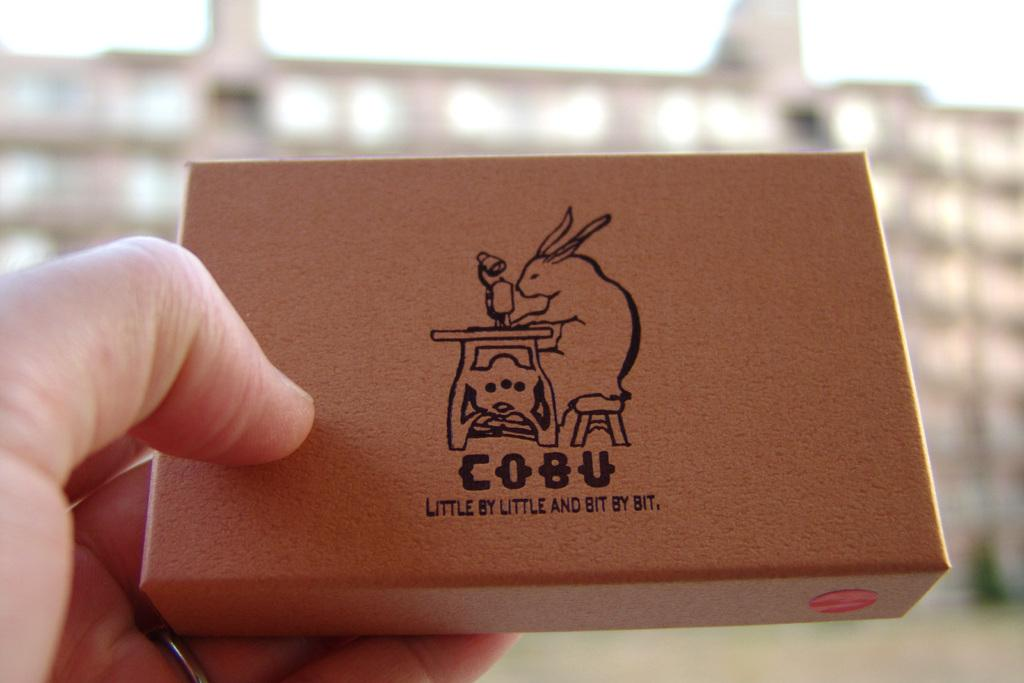Provide a one-sentence caption for the provided image. Someone holding a Cobu box with a rabbit sewing. 